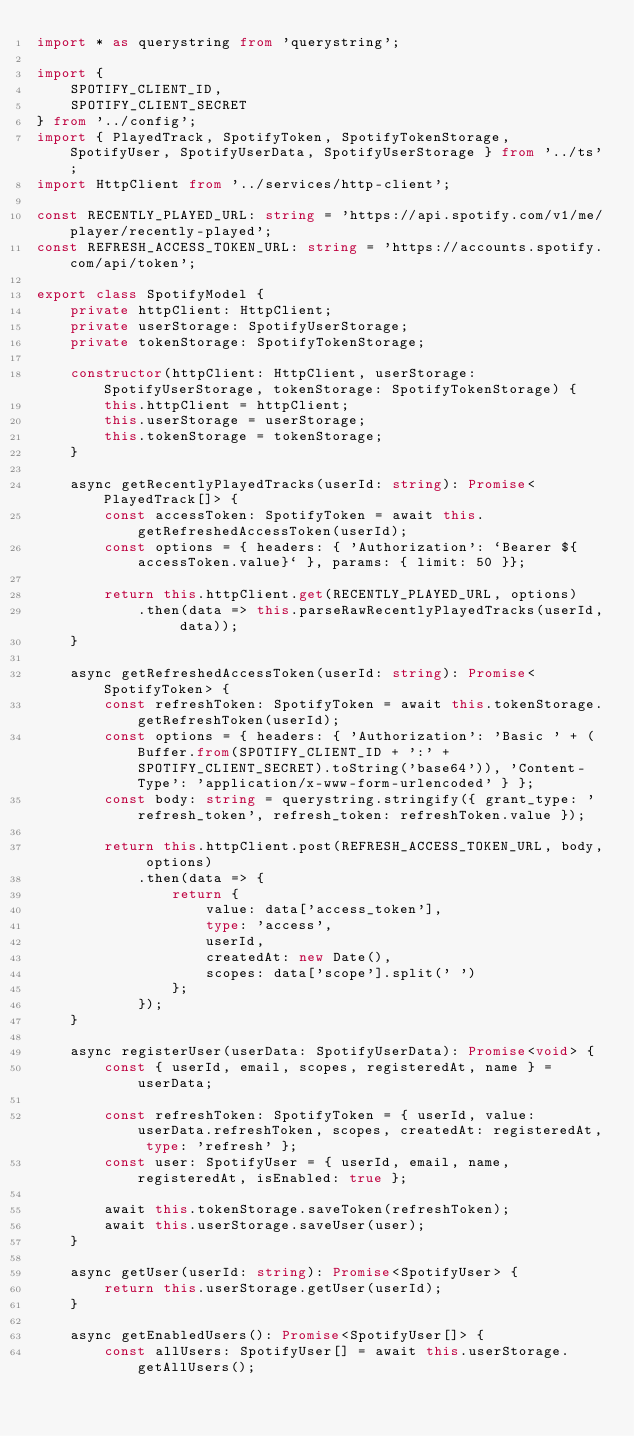Convert code to text. <code><loc_0><loc_0><loc_500><loc_500><_TypeScript_>import * as querystring from 'querystring';

import {
    SPOTIFY_CLIENT_ID,
    SPOTIFY_CLIENT_SECRET
} from '../config';
import { PlayedTrack, SpotifyToken, SpotifyTokenStorage, SpotifyUser, SpotifyUserData, SpotifyUserStorage } from '../ts';
import HttpClient from '../services/http-client';

const RECENTLY_PLAYED_URL: string = 'https://api.spotify.com/v1/me/player/recently-played';
const REFRESH_ACCESS_TOKEN_URL: string = 'https://accounts.spotify.com/api/token';

export class SpotifyModel {
    private httpClient: HttpClient;
    private userStorage: SpotifyUserStorage;
    private tokenStorage: SpotifyTokenStorage;

    constructor(httpClient: HttpClient, userStorage: SpotifyUserStorage, tokenStorage: SpotifyTokenStorage) {
        this.httpClient = httpClient;
        this.userStorage = userStorage;
        this.tokenStorage = tokenStorage;
    }

    async getRecentlyPlayedTracks(userId: string): Promise<PlayedTrack[]> {
        const accessToken: SpotifyToken = await this.getRefreshedAccessToken(userId);
        const options = { headers: { 'Authorization': `Bearer ${accessToken.value}` }, params: { limit: 50 }};

        return this.httpClient.get(RECENTLY_PLAYED_URL, options)
            .then(data => this.parseRawRecentlyPlayedTracks(userId, data));
    }

    async getRefreshedAccessToken(userId: string): Promise<SpotifyToken> {
        const refreshToken: SpotifyToken = await this.tokenStorage.getRefreshToken(userId);
        const options = { headers: { 'Authorization': 'Basic ' + (Buffer.from(SPOTIFY_CLIENT_ID + ':' + SPOTIFY_CLIENT_SECRET).toString('base64')), 'Content-Type': 'application/x-www-form-urlencoded' } };
        const body: string = querystring.stringify({ grant_type: 'refresh_token', refresh_token: refreshToken.value });

        return this.httpClient.post(REFRESH_ACCESS_TOKEN_URL, body, options)
            .then(data => {
                return {
                    value: data['access_token'],
                    type: 'access',
                    userId,
                    createdAt: new Date(),
                    scopes: data['scope'].split(' ')
                };
            });
    }

    async registerUser(userData: SpotifyUserData): Promise<void> {
        const { userId, email, scopes, registeredAt, name } = userData;

        const refreshToken: SpotifyToken = { userId, value: userData.refreshToken, scopes, createdAt: registeredAt, type: 'refresh' };
        const user: SpotifyUser = { userId, email, name, registeredAt, isEnabled: true };

        await this.tokenStorage.saveToken(refreshToken);
        await this.userStorage.saveUser(user);
    }

    async getUser(userId: string): Promise<SpotifyUser> {
        return this.userStorage.getUser(userId);
    }

    async getEnabledUsers(): Promise<SpotifyUser[]> {
        const allUsers: SpotifyUser[] = await this.userStorage.getAllUsers();</code> 